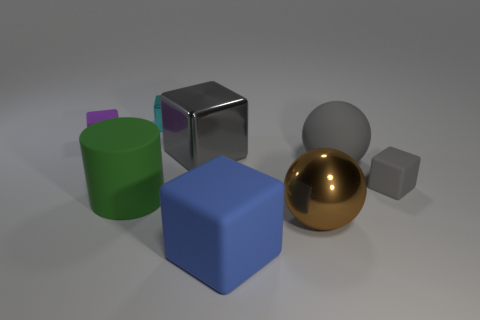There is a rubber object that is both behind the small gray cube and to the left of the small cyan thing; what size is it?
Offer a very short reply. Small. There is a big thing that is the same color as the big rubber ball; what material is it?
Make the answer very short. Metal. Is the number of cylinders that are behind the large green matte object the same as the number of brown objects?
Your answer should be very brief. No. Do the gray metallic cube and the blue object have the same size?
Offer a very short reply. Yes. There is a shiny object that is both in front of the small purple matte block and left of the big blue block; what is its color?
Provide a short and direct response. Gray. What material is the big sphere that is in front of the tiny thing in front of the small purple block made of?
Your response must be concise. Metal. There is a gray rubber thing that is the same shape as the blue rubber object; what size is it?
Keep it short and to the point. Small. Does the matte cube right of the large blue object have the same color as the matte sphere?
Offer a very short reply. Yes. Are there fewer big blue rubber things than big red balls?
Offer a very short reply. No. How many other objects are the same color as the matte ball?
Your answer should be compact. 2. 